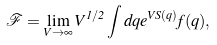<formula> <loc_0><loc_0><loc_500><loc_500>\mathcal { F } = \lim _ { V \to \infty } V ^ { 1 / 2 } \int d q e ^ { V S ( q ) } f ( q ) ,</formula> 